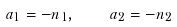Convert formula to latex. <formula><loc_0><loc_0><loc_500><loc_500>a _ { 1 } = - n _ { 1 } , \quad a _ { 2 } = - n _ { 2 }</formula> 